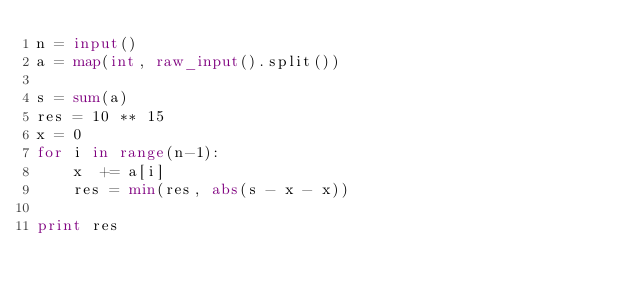Convert code to text. <code><loc_0><loc_0><loc_500><loc_500><_Python_>n = input()
a = map(int, raw_input().split())

s = sum(a)
res = 10 ** 15
x = 0
for i in range(n-1):
    x  += a[i]
    res = min(res, abs(s - x - x))

print res</code> 